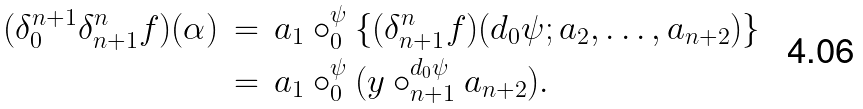<formula> <loc_0><loc_0><loc_500><loc_500>( \delta ^ { n + 1 } _ { 0 } \delta ^ { n } _ { n + 1 } f ) ( \alpha ) & \, = \, a _ { 1 } \circ ^ { \psi } _ { 0 } \{ ( \delta ^ { n } _ { n + 1 } f ) ( d _ { 0 } \psi ; a _ { 2 } , \dots , a _ { n + 2 } ) \} \\ & \, = \, a _ { 1 } \circ ^ { \psi } _ { 0 } ( y \circ ^ { d _ { 0 } \psi } _ { n + 1 } a _ { n + 2 } ) .</formula> 